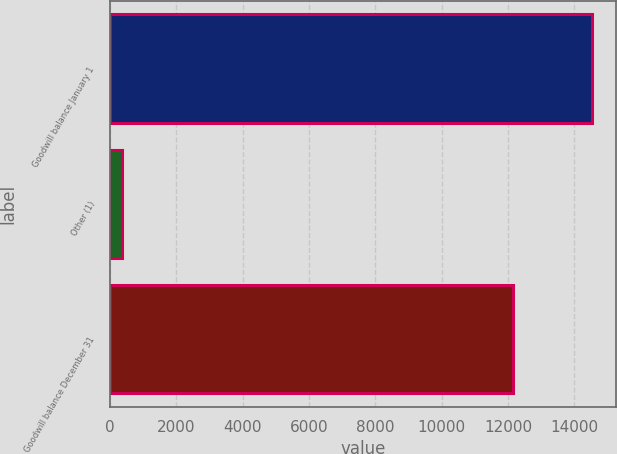<chart> <loc_0><loc_0><loc_500><loc_500><bar_chart><fcel>Goodwill balance January 1<fcel>Other (1)<fcel>Goodwill balance December 31<nl><fcel>14536.2<fcel>367<fcel>12134<nl></chart> 